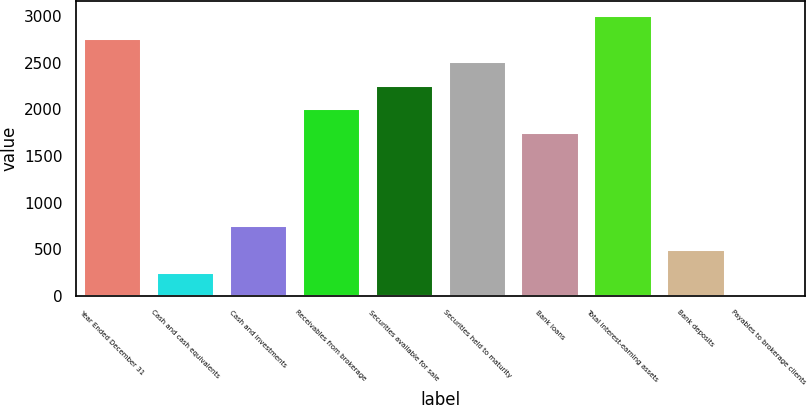Convert chart to OTSL. <chart><loc_0><loc_0><loc_500><loc_500><bar_chart><fcel>Year Ended December 31<fcel>Cash and cash equivalents<fcel>Cash and investments<fcel>Receivables from brokerage<fcel>Securities available for sale<fcel>Securities held to maturity<fcel>Bank loans<fcel>Total interest-earning assets<fcel>Bank deposits<fcel>Payables to brokerage clients<nl><fcel>2763<fcel>253<fcel>755<fcel>2010<fcel>2261<fcel>2512<fcel>1759<fcel>3014<fcel>504<fcel>2<nl></chart> 